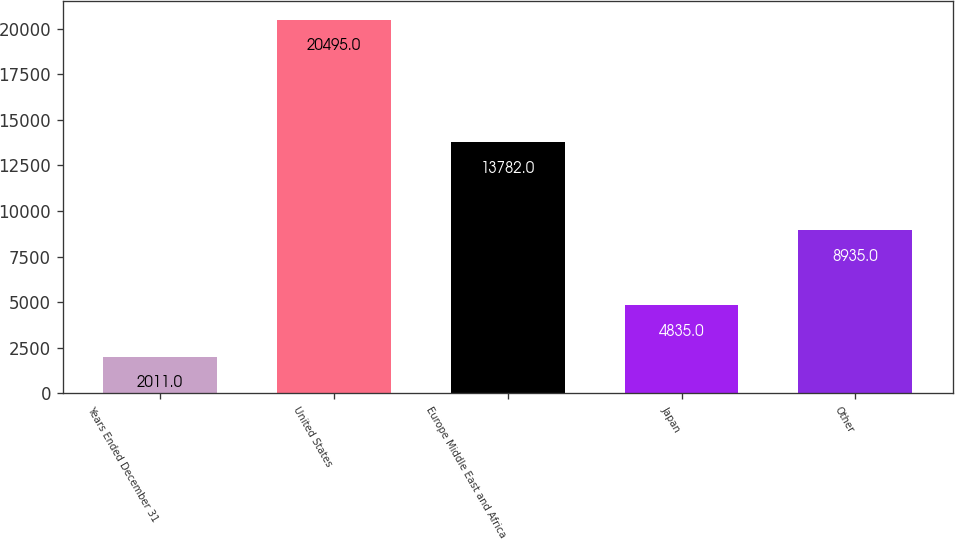<chart> <loc_0><loc_0><loc_500><loc_500><bar_chart><fcel>Years Ended December 31<fcel>United States<fcel>Europe Middle East and Africa<fcel>Japan<fcel>Other<nl><fcel>2011<fcel>20495<fcel>13782<fcel>4835<fcel>8935<nl></chart> 